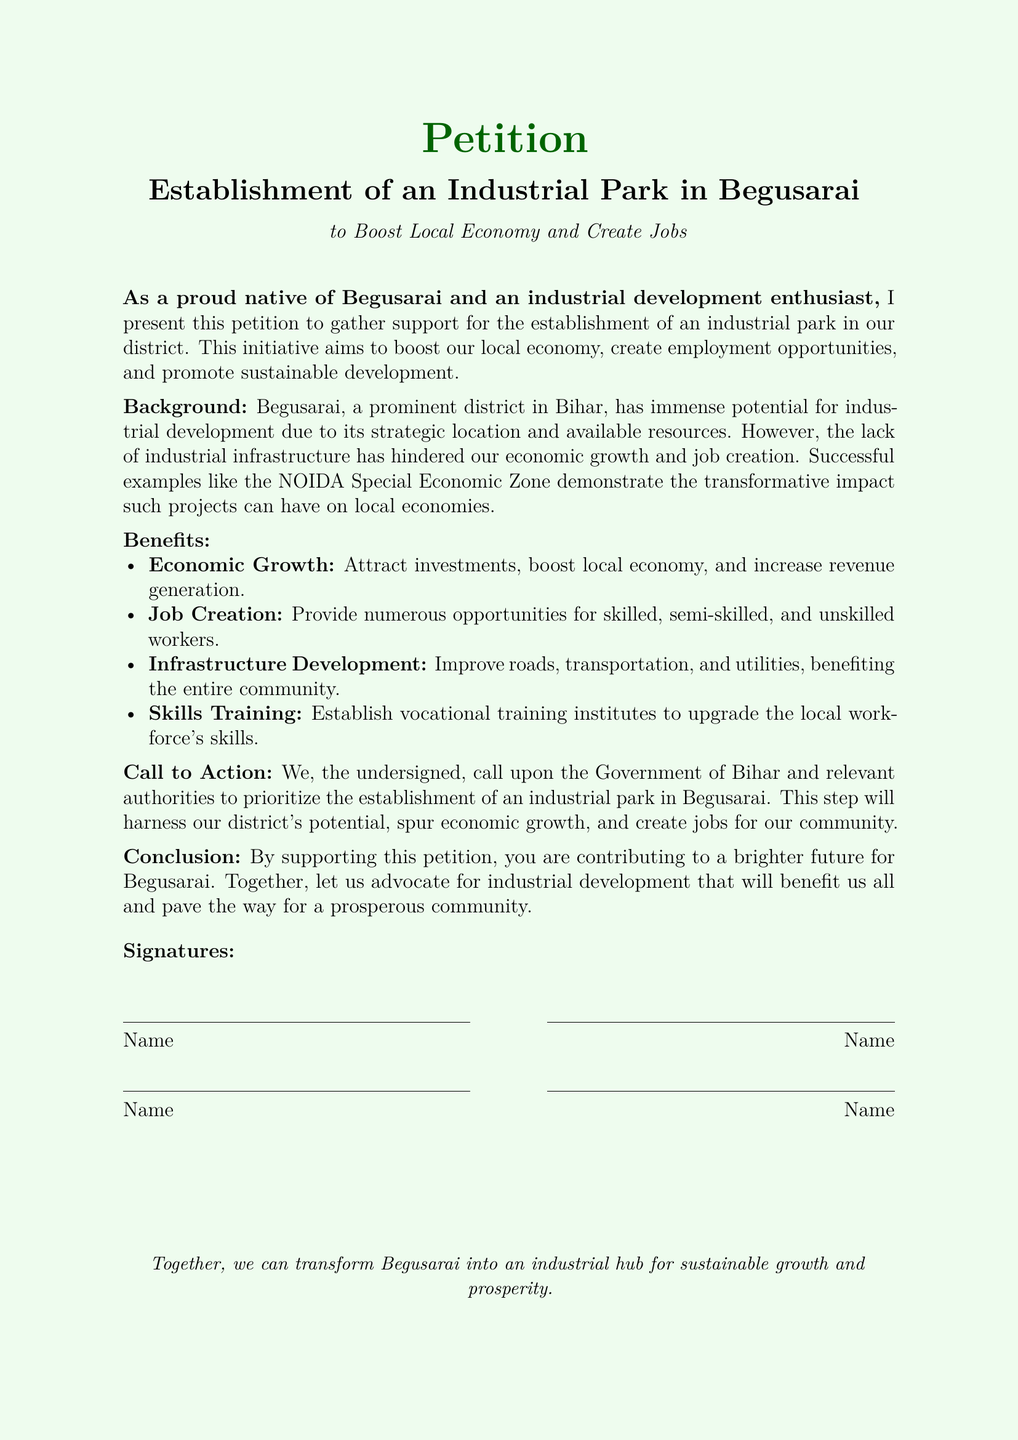What is the title of the petition? The title of the petition is explicitly stated in the document, which reads "Establishment of an Industrial Park in Begusarai."
Answer: Establishment of an Industrial Park in Begusarai What is the main purpose of the petition? The main purpose of the petition is described in the introductory section, highlighting the aim to boost the local economy and create jobs.
Answer: Boost local economy and create jobs Who is the petition addressed to? The petition is directed towards the Government of Bihar and relevant authorities, as mentioned in the "Call to Action" section.
Answer: Government of Bihar and relevant authorities What are the expected benefits listed in the petition? The benefits section outlines four key advantages, including economic growth, job creation, infrastructure development, and skills training.
Answer: Economic Growth, Job Creation, Infrastructure Development, Skills Training What successful example is mentioned in the document? The document refers to a specific location that serves as a successful example of industrial development, which is NOIDA Special Economic Zone.
Answer: NOIDA Special Economic Zone How many key benefits are listed in the petition? The benefits section contains a list that includes four distinct benefits supporting the main proposal.
Answer: Four What is the tone of the petition? The tone can be inferred from the language used throughout the document, which is encouraging and optimistic about the future of Begusarai.
Answer: Encouraging and optimistic What role do vocational training institutes play according to the petition? The role of vocational training institutes is to upgrade the skills of the local workforce, as indicated in the benefits described.
Answer: Upgrade the local workforce's skills What does the conclusion of the petition call for? The conclusion emphasizes the need for collective action to support the establishment of the industrial park and highlights its potential benefits for the community.
Answer: Collective action to support establishment of the industrial park 